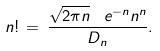Convert formula to latex. <formula><loc_0><loc_0><loc_500><loc_500>n ! \, = \, \frac { \sqrt { 2 \pi n } \, \ e ^ { - n } n ^ { n } } { D _ { n } } .</formula> 